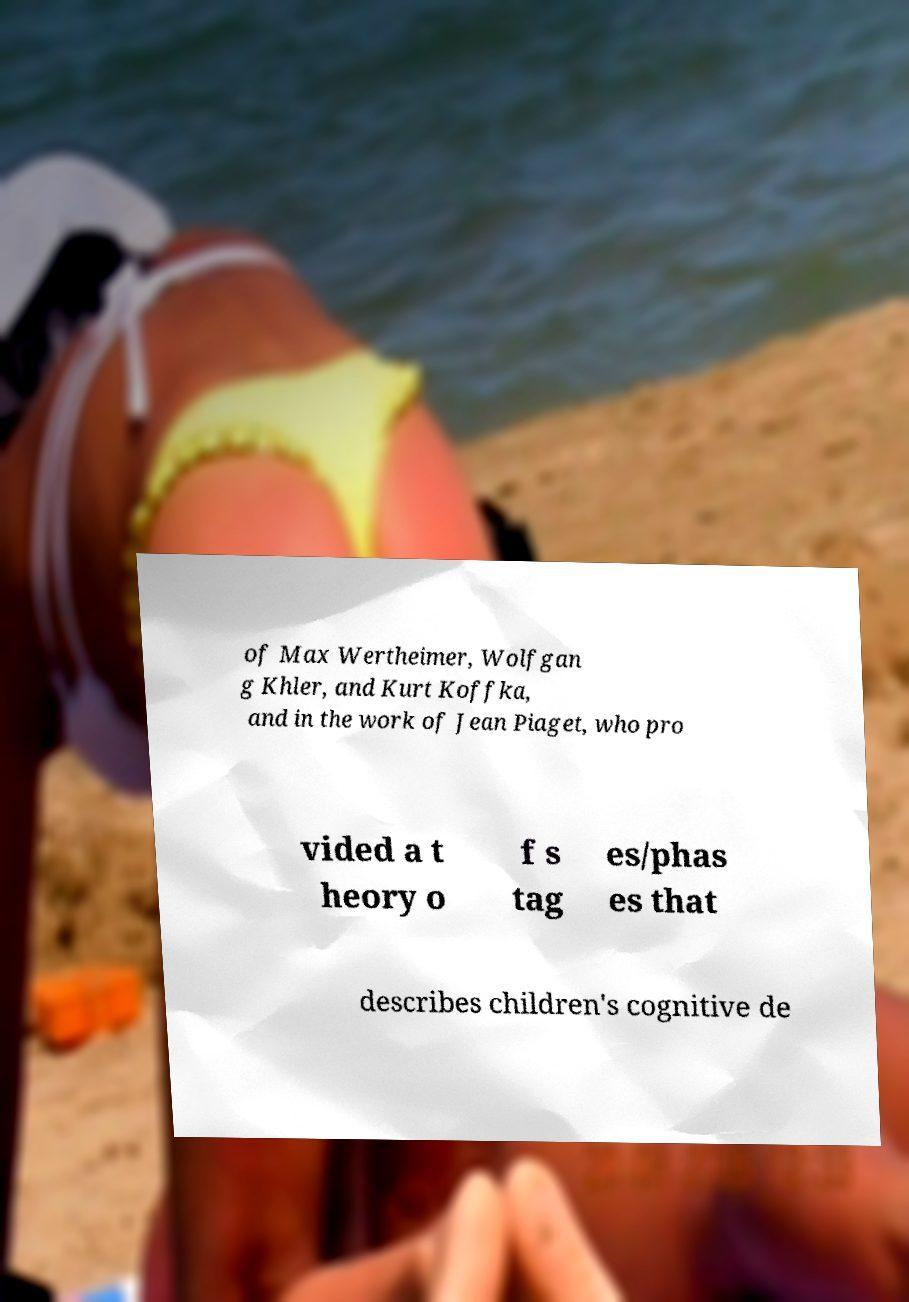Can you accurately transcribe the text from the provided image for me? of Max Wertheimer, Wolfgan g Khler, and Kurt Koffka, and in the work of Jean Piaget, who pro vided a t heory o f s tag es/phas es that describes children's cognitive de 